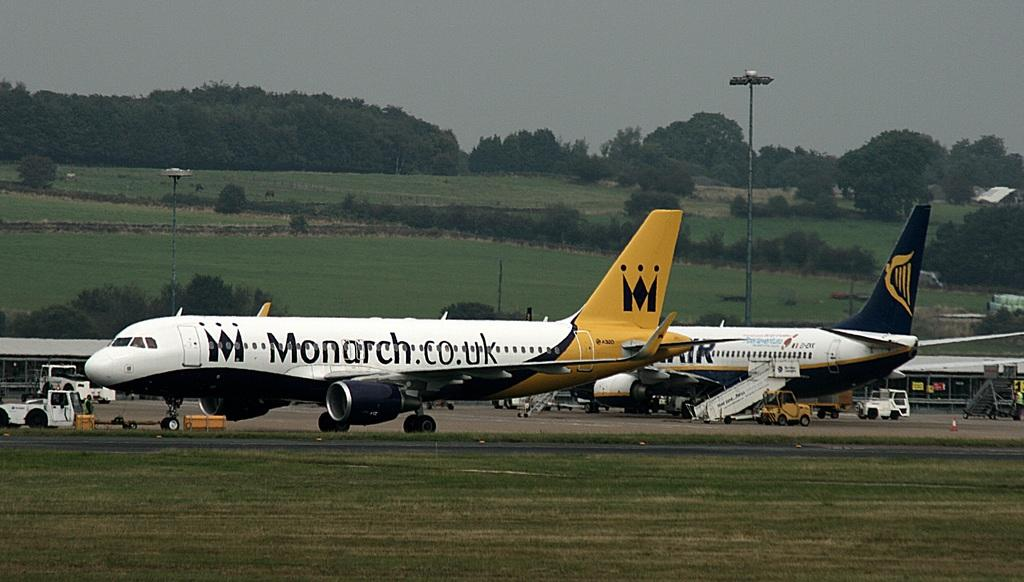<image>
Describe the image concisely. A plane advertising the website monarch.co.uk with the logo shown 